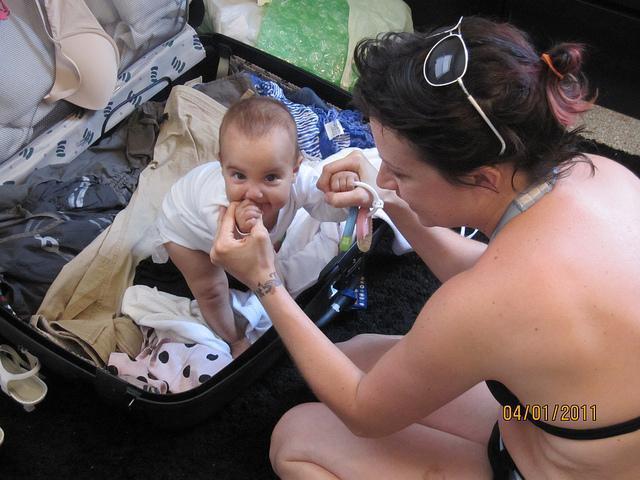How many people are there?
Give a very brief answer. 2. 